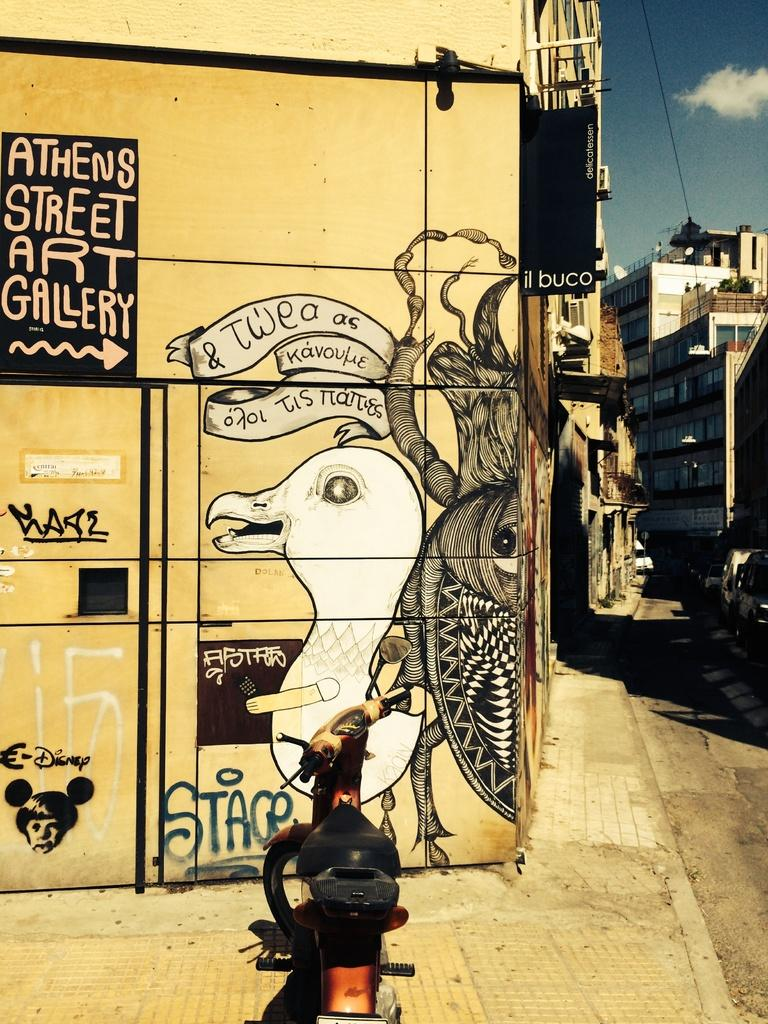<image>
Render a clear and concise summary of the photo. A yellow building has a picture of a dove and an arrow pointing to Athens Street Art Gallery. 